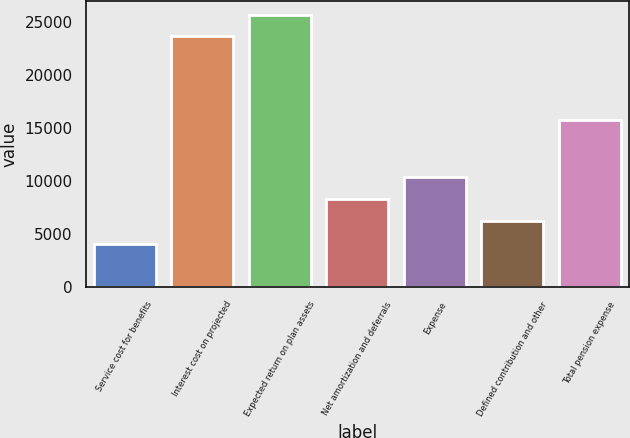Convert chart to OTSL. <chart><loc_0><loc_0><loc_500><loc_500><bar_chart><fcel>Service cost for benefits<fcel>Interest cost on projected<fcel>Expected return on plan assets<fcel>Net amortization and deferrals<fcel>Expense<fcel>Defined contribution and other<fcel>Total pension expense<nl><fcel>4080<fcel>23685<fcel>25738.6<fcel>8308.6<fcel>10362.2<fcel>6255<fcel>15817<nl></chart> 